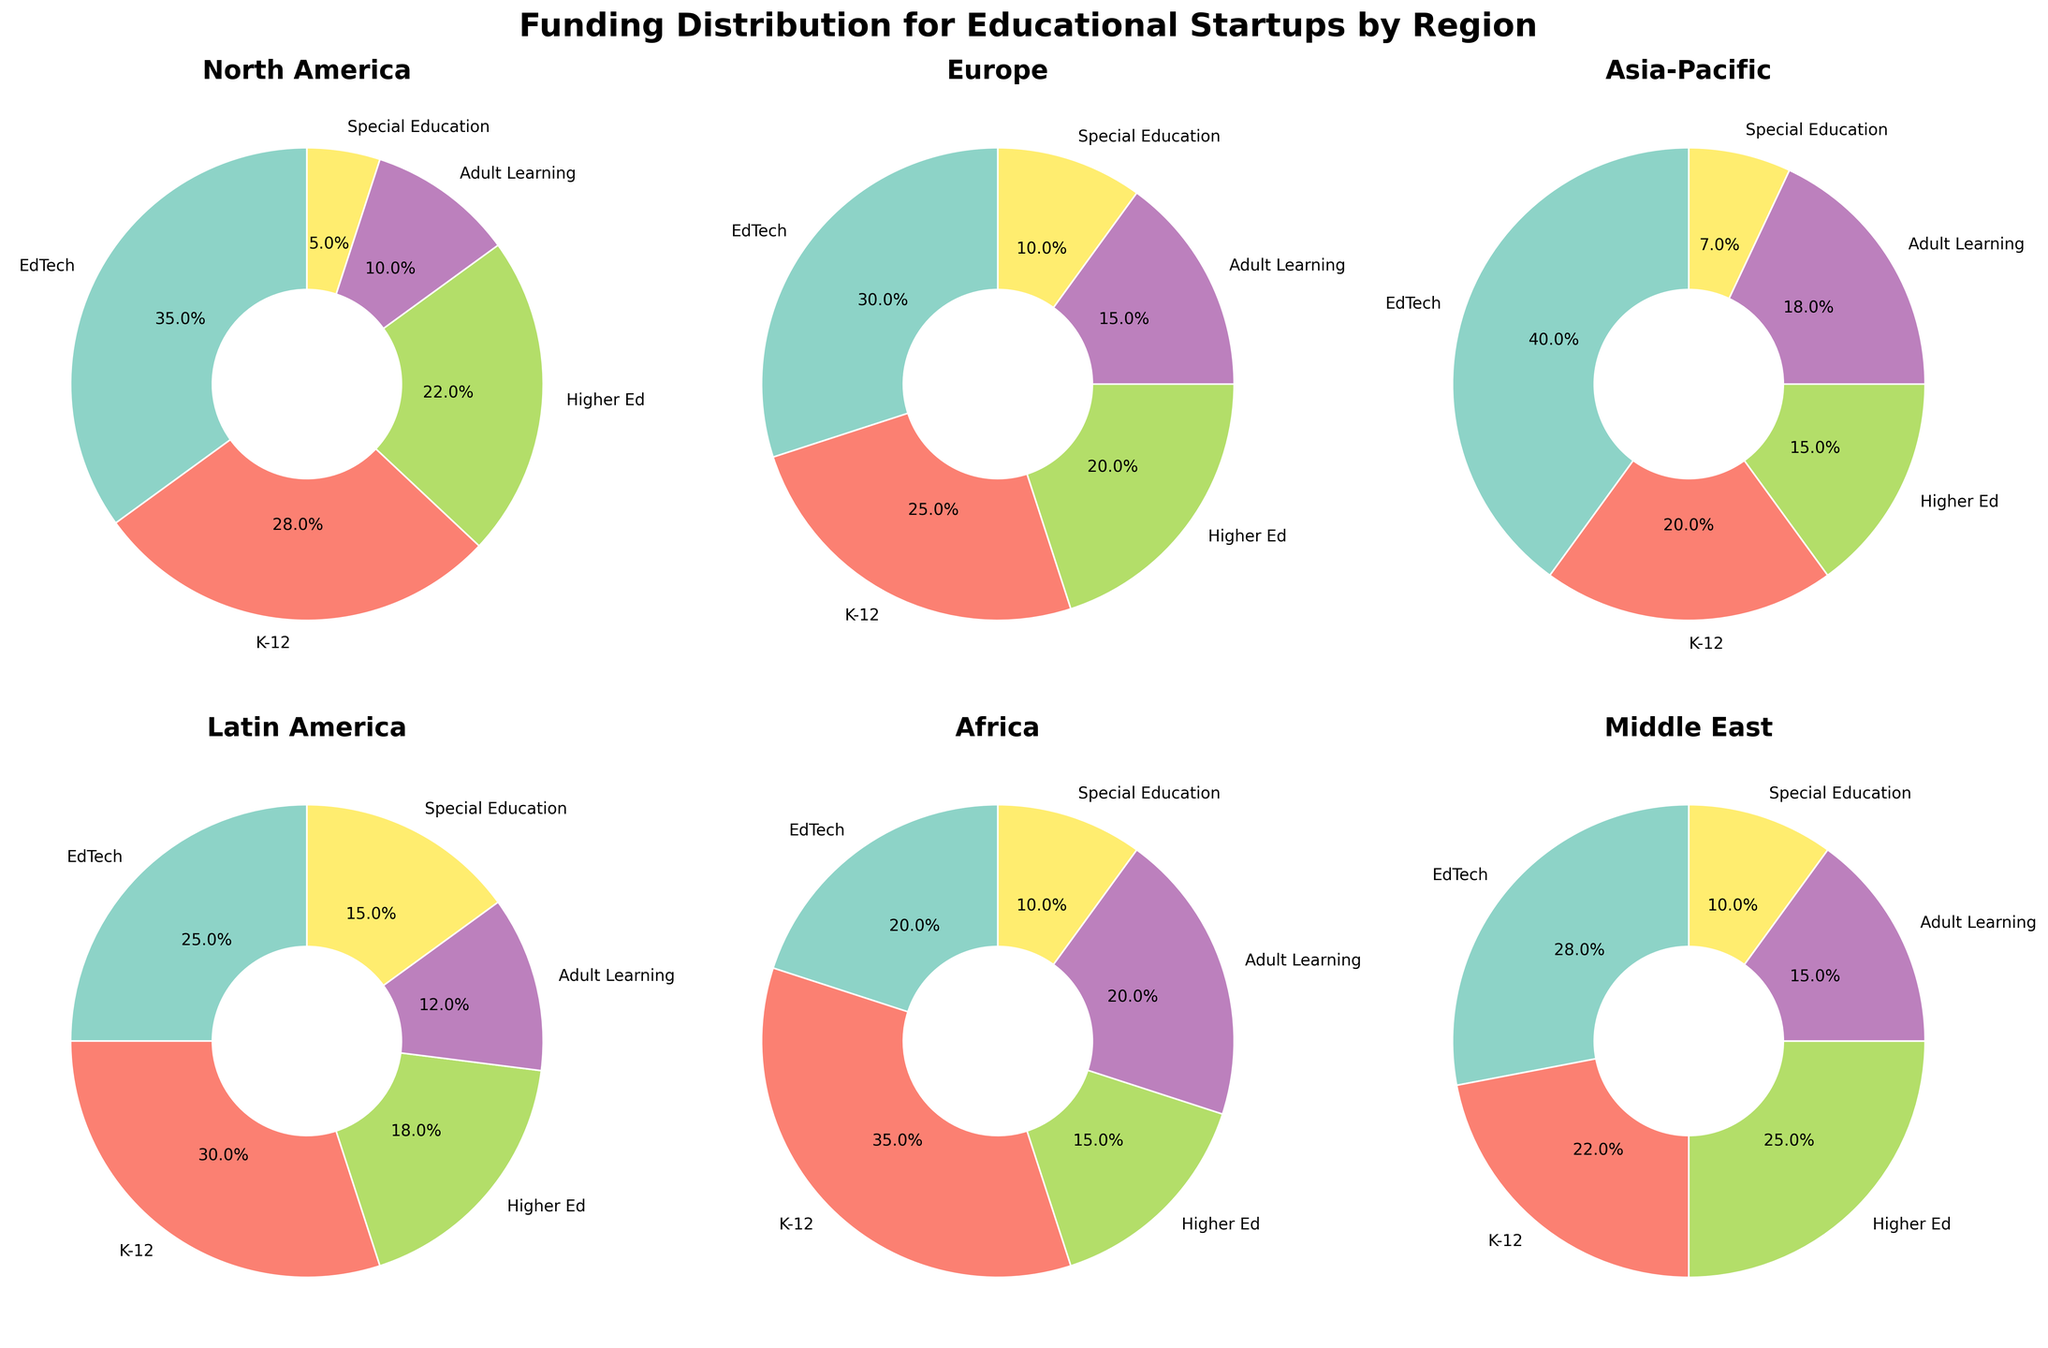What is the title of the figure? The main title of the figure is displayed at the top. It summarizes the content presented in the subplots.
Answer: Funding Distribution for Educational Startups by Region Which region has the highest funding percentage in the EdTech category? By examining each subplot, the region with the largest slice for the EdTech category (often visually distinguishable by its color) is observed.
Answer: Asia-Pacific What percentage of funding in North America goes to Special Education? The percentage for Special Education in North America's subplot can be directly read from the slice label.
Answer: 5% Compare the funding percentages between K-12 and Higher Ed in Europe. Which category receives more funding? In the Europe subplot, compare the slice sizes and their respective percentages labeled for K-12 and Higher Ed categories.
Answer: K-12 Summarize the funding distribution pattern for the Middle East region. Inspect the Middle East subplot and describe how the funding is divided among all five categories, specifying percentages labeled for each slice.
Answer: EdTech: 28%, K-12: 22%, Higher Ed: 25%, Adult Learning: 15%, Special Education: 10% Which region allocates 20% of its funding to Adult Learning? Look across all subplots and identify the region where the slice labeled “Adult Learning” represents 20% of the total funding.
Answer: Africa Between Latin America and Africa, which region allocates more funding to Higher Ed? Compare the Higher Ed slices in the subplots for Latin America and Africa by visually assessing their size and reading the percentages.
Answer: Latin America What is the total percentage of funding received by Special Education and Adult Learning categories in Europe? Sum the labeled percentages for Special Education and Adult Learning slices in the Europe subplot: Special Education (10%) + Adult Learning (15%).
Answer: 25% Which region has the most balanced funding distribution across all categories? Determine balance by comparing the sizes of slices in each subplot; the most balanced distribution means the slices are more equally sized.
Answer: Europe How does the funding pattern for K-12 in North America differ from that in Latin America? Analyze the K-12 slices in both North America and Latin America subplots and compare their sizes and labeled percentages (North America: 28%, Latin America: 30%).
Answer: Latin America allocates slightly more funding to K-12 than North America 